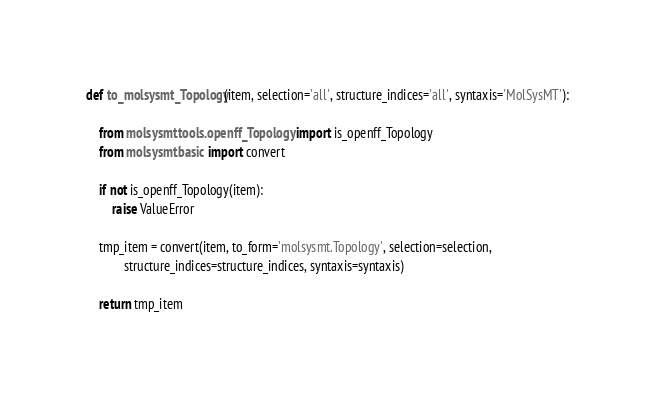Convert code to text. <code><loc_0><loc_0><loc_500><loc_500><_Python_>def to_molsysmt_Topology(item, selection='all', structure_indices='all', syntaxis='MolSysMT'):

    from molsysmt.tools.openff_Topology import is_openff_Topology
    from molsysmt.basic import convert

    if not is_openff_Topology(item):
        raise ValueError

    tmp_item = convert(item, to_form='molsysmt.Topology', selection=selection,
            structure_indices=structure_indices, syntaxis=syntaxis)

    return tmp_item

</code> 